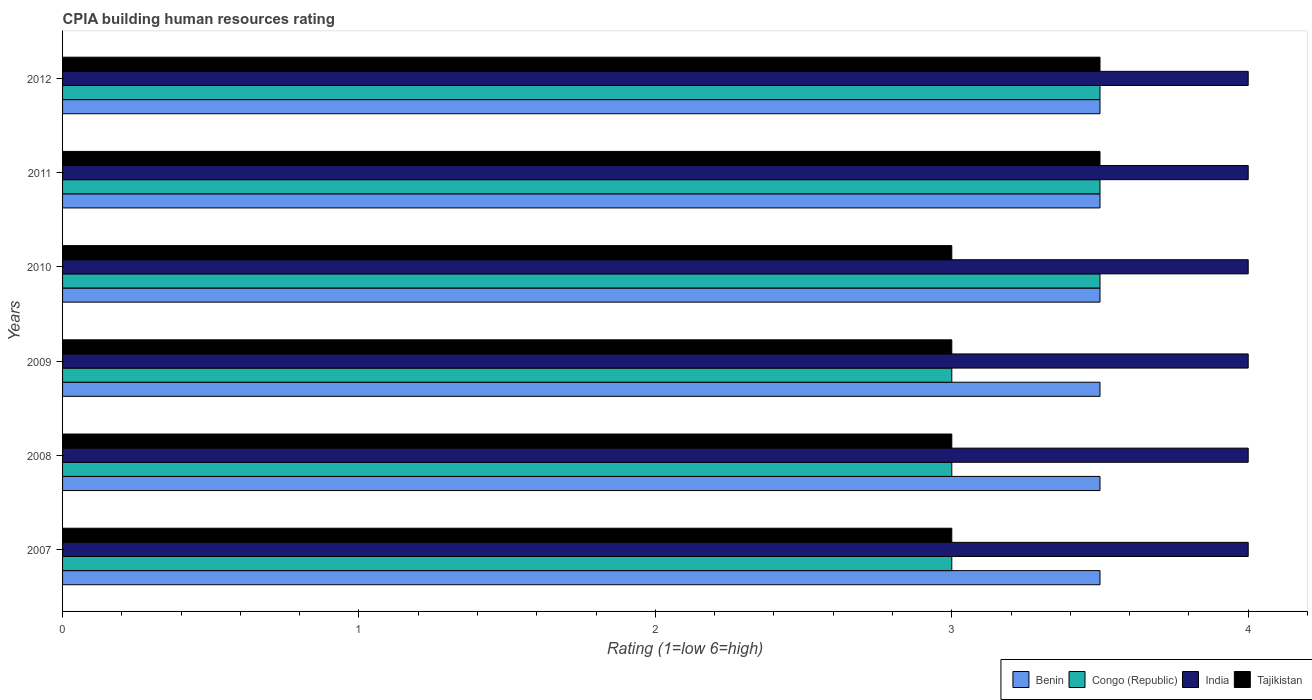What is the label of the 2nd group of bars from the top?
Provide a succinct answer. 2011. In how many cases, is the number of bars for a given year not equal to the number of legend labels?
Keep it short and to the point. 0. Across all years, what is the minimum CPIA rating in Congo (Republic)?
Your response must be concise. 3. In which year was the CPIA rating in Tajikistan maximum?
Keep it short and to the point. 2011. In which year was the CPIA rating in India minimum?
Your response must be concise. 2007. What is the difference between the CPIA rating in Tajikistan in 2007 and that in 2011?
Your answer should be very brief. -0.5. In the year 2009, what is the difference between the CPIA rating in Congo (Republic) and CPIA rating in Tajikistan?
Offer a very short reply. 0. Is the CPIA rating in India in 2009 less than that in 2011?
Your answer should be compact. No. Is the difference between the CPIA rating in Congo (Republic) in 2008 and 2012 greater than the difference between the CPIA rating in Tajikistan in 2008 and 2012?
Keep it short and to the point. No. What is the difference between the highest and the second highest CPIA rating in Congo (Republic)?
Keep it short and to the point. 0. What is the difference between the highest and the lowest CPIA rating in Benin?
Provide a succinct answer. 0. In how many years, is the CPIA rating in India greater than the average CPIA rating in India taken over all years?
Offer a terse response. 0. Is the sum of the CPIA rating in Congo (Republic) in 2010 and 2012 greater than the maximum CPIA rating in India across all years?
Your answer should be very brief. Yes. What does the 1st bar from the bottom in 2011 represents?
Your answer should be very brief. Benin. Is it the case that in every year, the sum of the CPIA rating in India and CPIA rating in Congo (Republic) is greater than the CPIA rating in Tajikistan?
Your response must be concise. Yes. Are all the bars in the graph horizontal?
Your answer should be compact. Yes. How many years are there in the graph?
Keep it short and to the point. 6. What is the difference between two consecutive major ticks on the X-axis?
Offer a very short reply. 1. Does the graph contain any zero values?
Ensure brevity in your answer.  No. Does the graph contain grids?
Give a very brief answer. No. Where does the legend appear in the graph?
Make the answer very short. Bottom right. How are the legend labels stacked?
Provide a short and direct response. Horizontal. What is the title of the graph?
Give a very brief answer. CPIA building human resources rating. What is the Rating (1=low 6=high) in Benin in 2007?
Your answer should be compact. 3.5. What is the Rating (1=low 6=high) of Congo (Republic) in 2007?
Offer a terse response. 3. What is the Rating (1=low 6=high) in Tajikistan in 2007?
Provide a short and direct response. 3. What is the Rating (1=low 6=high) of Benin in 2008?
Keep it short and to the point. 3.5. What is the Rating (1=low 6=high) in Congo (Republic) in 2008?
Make the answer very short. 3. What is the Rating (1=low 6=high) of India in 2008?
Keep it short and to the point. 4. What is the Rating (1=low 6=high) of Benin in 2009?
Give a very brief answer. 3.5. What is the Rating (1=low 6=high) in Congo (Republic) in 2009?
Ensure brevity in your answer.  3. What is the Rating (1=low 6=high) of India in 2009?
Give a very brief answer. 4. What is the Rating (1=low 6=high) in Tajikistan in 2009?
Offer a very short reply. 3. What is the Rating (1=low 6=high) of Benin in 2010?
Keep it short and to the point. 3.5. What is the Rating (1=low 6=high) of Benin in 2011?
Provide a succinct answer. 3.5. What is the Rating (1=low 6=high) of India in 2011?
Ensure brevity in your answer.  4. What is the Rating (1=low 6=high) in Tajikistan in 2011?
Offer a very short reply. 3.5. What is the Rating (1=low 6=high) in Benin in 2012?
Offer a terse response. 3.5. What is the Rating (1=low 6=high) of Tajikistan in 2012?
Give a very brief answer. 3.5. Across all years, what is the maximum Rating (1=low 6=high) in Congo (Republic)?
Provide a short and direct response. 3.5. Across all years, what is the maximum Rating (1=low 6=high) in India?
Offer a very short reply. 4. Across all years, what is the minimum Rating (1=low 6=high) in Congo (Republic)?
Keep it short and to the point. 3. What is the total Rating (1=low 6=high) in Congo (Republic) in the graph?
Keep it short and to the point. 19.5. What is the total Rating (1=low 6=high) in India in the graph?
Offer a terse response. 24. What is the total Rating (1=low 6=high) in Tajikistan in the graph?
Give a very brief answer. 19. What is the difference between the Rating (1=low 6=high) of Benin in 2007 and that in 2008?
Make the answer very short. 0. What is the difference between the Rating (1=low 6=high) in Congo (Republic) in 2007 and that in 2008?
Your answer should be very brief. 0. What is the difference between the Rating (1=low 6=high) in Tajikistan in 2007 and that in 2008?
Your response must be concise. 0. What is the difference between the Rating (1=low 6=high) of Congo (Republic) in 2007 and that in 2009?
Give a very brief answer. 0. What is the difference between the Rating (1=low 6=high) in Congo (Republic) in 2007 and that in 2011?
Ensure brevity in your answer.  -0.5. What is the difference between the Rating (1=low 6=high) in India in 2007 and that in 2011?
Your answer should be very brief. 0. What is the difference between the Rating (1=low 6=high) of Tajikistan in 2007 and that in 2011?
Provide a succinct answer. -0.5. What is the difference between the Rating (1=low 6=high) of India in 2007 and that in 2012?
Your response must be concise. 0. What is the difference between the Rating (1=low 6=high) in Tajikistan in 2007 and that in 2012?
Make the answer very short. -0.5. What is the difference between the Rating (1=low 6=high) of India in 2008 and that in 2009?
Your answer should be compact. 0. What is the difference between the Rating (1=low 6=high) in Tajikistan in 2008 and that in 2009?
Offer a terse response. 0. What is the difference between the Rating (1=low 6=high) of Benin in 2008 and that in 2010?
Ensure brevity in your answer.  0. What is the difference between the Rating (1=low 6=high) in India in 2008 and that in 2010?
Ensure brevity in your answer.  0. What is the difference between the Rating (1=low 6=high) of Tajikistan in 2008 and that in 2010?
Provide a short and direct response. 0. What is the difference between the Rating (1=low 6=high) of Benin in 2008 and that in 2011?
Offer a terse response. 0. What is the difference between the Rating (1=low 6=high) in Congo (Republic) in 2008 and that in 2011?
Offer a terse response. -0.5. What is the difference between the Rating (1=low 6=high) in India in 2009 and that in 2010?
Give a very brief answer. 0. What is the difference between the Rating (1=low 6=high) in Benin in 2009 and that in 2011?
Offer a very short reply. 0. What is the difference between the Rating (1=low 6=high) in Congo (Republic) in 2009 and that in 2011?
Offer a terse response. -0.5. What is the difference between the Rating (1=low 6=high) in Tajikistan in 2009 and that in 2011?
Keep it short and to the point. -0.5. What is the difference between the Rating (1=low 6=high) in Congo (Republic) in 2009 and that in 2012?
Provide a succinct answer. -0.5. What is the difference between the Rating (1=low 6=high) of Tajikistan in 2009 and that in 2012?
Provide a short and direct response. -0.5. What is the difference between the Rating (1=low 6=high) in Benin in 2010 and that in 2011?
Make the answer very short. 0. What is the difference between the Rating (1=low 6=high) of Congo (Republic) in 2010 and that in 2011?
Ensure brevity in your answer.  0. What is the difference between the Rating (1=low 6=high) of India in 2010 and that in 2011?
Offer a very short reply. 0. What is the difference between the Rating (1=low 6=high) in Tajikistan in 2010 and that in 2012?
Give a very brief answer. -0.5. What is the difference between the Rating (1=low 6=high) in Benin in 2011 and that in 2012?
Make the answer very short. 0. What is the difference between the Rating (1=low 6=high) of India in 2011 and that in 2012?
Offer a terse response. 0. What is the difference between the Rating (1=low 6=high) in Benin in 2007 and the Rating (1=low 6=high) in Congo (Republic) in 2008?
Your response must be concise. 0.5. What is the difference between the Rating (1=low 6=high) of India in 2007 and the Rating (1=low 6=high) of Tajikistan in 2008?
Your response must be concise. 1. What is the difference between the Rating (1=low 6=high) of Benin in 2007 and the Rating (1=low 6=high) of Congo (Republic) in 2009?
Make the answer very short. 0.5. What is the difference between the Rating (1=low 6=high) of Benin in 2007 and the Rating (1=low 6=high) of India in 2009?
Offer a terse response. -0.5. What is the difference between the Rating (1=low 6=high) of Benin in 2007 and the Rating (1=low 6=high) of Tajikistan in 2009?
Your answer should be compact. 0.5. What is the difference between the Rating (1=low 6=high) of Congo (Republic) in 2007 and the Rating (1=low 6=high) of India in 2009?
Your answer should be compact. -1. What is the difference between the Rating (1=low 6=high) in Benin in 2007 and the Rating (1=low 6=high) in Congo (Republic) in 2010?
Give a very brief answer. 0. What is the difference between the Rating (1=low 6=high) of Benin in 2007 and the Rating (1=low 6=high) of India in 2010?
Keep it short and to the point. -0.5. What is the difference between the Rating (1=low 6=high) of Benin in 2007 and the Rating (1=low 6=high) of Tajikistan in 2010?
Your answer should be very brief. 0.5. What is the difference between the Rating (1=low 6=high) in Congo (Republic) in 2007 and the Rating (1=low 6=high) in India in 2010?
Ensure brevity in your answer.  -1. What is the difference between the Rating (1=low 6=high) in India in 2007 and the Rating (1=low 6=high) in Tajikistan in 2010?
Keep it short and to the point. 1. What is the difference between the Rating (1=low 6=high) of Congo (Republic) in 2007 and the Rating (1=low 6=high) of India in 2011?
Provide a short and direct response. -1. What is the difference between the Rating (1=low 6=high) of Congo (Republic) in 2007 and the Rating (1=low 6=high) of Tajikistan in 2011?
Make the answer very short. -0.5. What is the difference between the Rating (1=low 6=high) of India in 2007 and the Rating (1=low 6=high) of Tajikistan in 2011?
Offer a terse response. 0.5. What is the difference between the Rating (1=low 6=high) of Benin in 2007 and the Rating (1=low 6=high) of Congo (Republic) in 2012?
Provide a short and direct response. 0. What is the difference between the Rating (1=low 6=high) in Benin in 2007 and the Rating (1=low 6=high) in India in 2012?
Your response must be concise. -0.5. What is the difference between the Rating (1=low 6=high) of Benin in 2007 and the Rating (1=low 6=high) of Tajikistan in 2012?
Keep it short and to the point. 0. What is the difference between the Rating (1=low 6=high) in Congo (Republic) in 2007 and the Rating (1=low 6=high) in India in 2012?
Ensure brevity in your answer.  -1. What is the difference between the Rating (1=low 6=high) of Congo (Republic) in 2007 and the Rating (1=low 6=high) of Tajikistan in 2012?
Make the answer very short. -0.5. What is the difference between the Rating (1=low 6=high) in Benin in 2008 and the Rating (1=low 6=high) in India in 2009?
Offer a very short reply. -0.5. What is the difference between the Rating (1=low 6=high) of Congo (Republic) in 2008 and the Rating (1=low 6=high) of India in 2010?
Ensure brevity in your answer.  -1. What is the difference between the Rating (1=low 6=high) of Benin in 2008 and the Rating (1=low 6=high) of Congo (Republic) in 2011?
Your answer should be compact. 0. What is the difference between the Rating (1=low 6=high) in Benin in 2008 and the Rating (1=low 6=high) in Tajikistan in 2011?
Offer a terse response. 0. What is the difference between the Rating (1=low 6=high) of Congo (Republic) in 2008 and the Rating (1=low 6=high) of Tajikistan in 2011?
Ensure brevity in your answer.  -0.5. What is the difference between the Rating (1=low 6=high) of Benin in 2008 and the Rating (1=low 6=high) of India in 2012?
Give a very brief answer. -0.5. What is the difference between the Rating (1=low 6=high) in India in 2008 and the Rating (1=low 6=high) in Tajikistan in 2012?
Give a very brief answer. 0.5. What is the difference between the Rating (1=low 6=high) in Benin in 2009 and the Rating (1=low 6=high) in India in 2010?
Offer a very short reply. -0.5. What is the difference between the Rating (1=low 6=high) in Benin in 2009 and the Rating (1=low 6=high) in Tajikistan in 2010?
Your answer should be compact. 0.5. What is the difference between the Rating (1=low 6=high) of Congo (Republic) in 2009 and the Rating (1=low 6=high) of Tajikistan in 2010?
Your answer should be compact. 0. What is the difference between the Rating (1=low 6=high) of India in 2009 and the Rating (1=low 6=high) of Tajikistan in 2010?
Give a very brief answer. 1. What is the difference between the Rating (1=low 6=high) in Congo (Republic) in 2009 and the Rating (1=low 6=high) in India in 2011?
Your response must be concise. -1. What is the difference between the Rating (1=low 6=high) of India in 2009 and the Rating (1=low 6=high) of Tajikistan in 2011?
Give a very brief answer. 0.5. What is the difference between the Rating (1=low 6=high) of Benin in 2009 and the Rating (1=low 6=high) of Congo (Republic) in 2012?
Provide a short and direct response. 0. What is the difference between the Rating (1=low 6=high) in Benin in 2009 and the Rating (1=low 6=high) in India in 2012?
Ensure brevity in your answer.  -0.5. What is the difference between the Rating (1=low 6=high) of Benin in 2009 and the Rating (1=low 6=high) of Tajikistan in 2012?
Your answer should be compact. 0. What is the difference between the Rating (1=low 6=high) of Congo (Republic) in 2009 and the Rating (1=low 6=high) of Tajikistan in 2012?
Offer a very short reply. -0.5. What is the difference between the Rating (1=low 6=high) of India in 2009 and the Rating (1=low 6=high) of Tajikistan in 2012?
Keep it short and to the point. 0.5. What is the difference between the Rating (1=low 6=high) in Benin in 2010 and the Rating (1=low 6=high) in Congo (Republic) in 2011?
Keep it short and to the point. 0. What is the difference between the Rating (1=low 6=high) of Benin in 2010 and the Rating (1=low 6=high) of Tajikistan in 2011?
Your response must be concise. 0. What is the difference between the Rating (1=low 6=high) in Congo (Republic) in 2010 and the Rating (1=low 6=high) in India in 2011?
Your answer should be very brief. -0.5. What is the difference between the Rating (1=low 6=high) in Congo (Republic) in 2010 and the Rating (1=low 6=high) in Tajikistan in 2011?
Ensure brevity in your answer.  0. What is the difference between the Rating (1=low 6=high) in India in 2010 and the Rating (1=low 6=high) in Tajikistan in 2011?
Provide a succinct answer. 0.5. What is the difference between the Rating (1=low 6=high) of Benin in 2010 and the Rating (1=low 6=high) of India in 2012?
Offer a terse response. -0.5. What is the difference between the Rating (1=low 6=high) of Benin in 2010 and the Rating (1=low 6=high) of Tajikistan in 2012?
Your answer should be compact. 0. What is the difference between the Rating (1=low 6=high) of Congo (Republic) in 2010 and the Rating (1=low 6=high) of India in 2012?
Your answer should be compact. -0.5. What is the difference between the Rating (1=low 6=high) of Congo (Republic) in 2010 and the Rating (1=low 6=high) of Tajikistan in 2012?
Make the answer very short. 0. What is the difference between the Rating (1=low 6=high) in Benin in 2011 and the Rating (1=low 6=high) in Congo (Republic) in 2012?
Ensure brevity in your answer.  0. What is the difference between the Rating (1=low 6=high) of Benin in 2011 and the Rating (1=low 6=high) of India in 2012?
Provide a succinct answer. -0.5. What is the difference between the Rating (1=low 6=high) of Congo (Republic) in 2011 and the Rating (1=low 6=high) of Tajikistan in 2012?
Offer a very short reply. 0. What is the average Rating (1=low 6=high) of Congo (Republic) per year?
Your answer should be very brief. 3.25. What is the average Rating (1=low 6=high) of Tajikistan per year?
Offer a very short reply. 3.17. In the year 2007, what is the difference between the Rating (1=low 6=high) in Congo (Republic) and Rating (1=low 6=high) in India?
Provide a short and direct response. -1. In the year 2007, what is the difference between the Rating (1=low 6=high) of Congo (Republic) and Rating (1=low 6=high) of Tajikistan?
Provide a short and direct response. 0. In the year 2008, what is the difference between the Rating (1=low 6=high) of Benin and Rating (1=low 6=high) of Congo (Republic)?
Give a very brief answer. 0.5. In the year 2008, what is the difference between the Rating (1=low 6=high) in Benin and Rating (1=low 6=high) in Tajikistan?
Offer a terse response. 0.5. In the year 2008, what is the difference between the Rating (1=low 6=high) of Congo (Republic) and Rating (1=low 6=high) of India?
Ensure brevity in your answer.  -1. In the year 2008, what is the difference between the Rating (1=low 6=high) of Congo (Republic) and Rating (1=low 6=high) of Tajikistan?
Make the answer very short. 0. In the year 2009, what is the difference between the Rating (1=low 6=high) in Benin and Rating (1=low 6=high) in India?
Your response must be concise. -0.5. In the year 2009, what is the difference between the Rating (1=low 6=high) in Congo (Republic) and Rating (1=low 6=high) in India?
Provide a short and direct response. -1. In the year 2009, what is the difference between the Rating (1=low 6=high) of Congo (Republic) and Rating (1=low 6=high) of Tajikistan?
Your answer should be compact. 0. In the year 2010, what is the difference between the Rating (1=low 6=high) in Benin and Rating (1=low 6=high) in Congo (Republic)?
Keep it short and to the point. 0. In the year 2010, what is the difference between the Rating (1=low 6=high) of Benin and Rating (1=low 6=high) of India?
Your answer should be compact. -0.5. In the year 2010, what is the difference between the Rating (1=low 6=high) of Benin and Rating (1=low 6=high) of Tajikistan?
Give a very brief answer. 0.5. In the year 2010, what is the difference between the Rating (1=low 6=high) in Congo (Republic) and Rating (1=low 6=high) in Tajikistan?
Provide a succinct answer. 0.5. In the year 2010, what is the difference between the Rating (1=low 6=high) in India and Rating (1=low 6=high) in Tajikistan?
Keep it short and to the point. 1. In the year 2011, what is the difference between the Rating (1=low 6=high) in Benin and Rating (1=low 6=high) in Congo (Republic)?
Make the answer very short. 0. In the year 2011, what is the difference between the Rating (1=low 6=high) in Benin and Rating (1=low 6=high) in India?
Provide a succinct answer. -0.5. In the year 2011, what is the difference between the Rating (1=low 6=high) of Benin and Rating (1=low 6=high) of Tajikistan?
Offer a terse response. 0. In the year 2011, what is the difference between the Rating (1=low 6=high) of India and Rating (1=low 6=high) of Tajikistan?
Ensure brevity in your answer.  0.5. In the year 2012, what is the difference between the Rating (1=low 6=high) of Benin and Rating (1=low 6=high) of India?
Provide a succinct answer. -0.5. In the year 2012, what is the difference between the Rating (1=low 6=high) in Congo (Republic) and Rating (1=low 6=high) in Tajikistan?
Keep it short and to the point. 0. What is the ratio of the Rating (1=low 6=high) of Tajikistan in 2007 to that in 2008?
Make the answer very short. 1. What is the ratio of the Rating (1=low 6=high) in India in 2007 to that in 2009?
Make the answer very short. 1. What is the ratio of the Rating (1=low 6=high) in Tajikistan in 2007 to that in 2009?
Keep it short and to the point. 1. What is the ratio of the Rating (1=low 6=high) of Benin in 2007 to that in 2010?
Your response must be concise. 1. What is the ratio of the Rating (1=low 6=high) in Congo (Republic) in 2007 to that in 2010?
Offer a very short reply. 0.86. What is the ratio of the Rating (1=low 6=high) in Congo (Republic) in 2007 to that in 2011?
Keep it short and to the point. 0.86. What is the ratio of the Rating (1=low 6=high) of Tajikistan in 2007 to that in 2011?
Make the answer very short. 0.86. What is the ratio of the Rating (1=low 6=high) in India in 2007 to that in 2012?
Provide a succinct answer. 1. What is the ratio of the Rating (1=low 6=high) of Benin in 2008 to that in 2009?
Offer a very short reply. 1. What is the ratio of the Rating (1=low 6=high) in Tajikistan in 2008 to that in 2009?
Make the answer very short. 1. What is the ratio of the Rating (1=low 6=high) of Benin in 2008 to that in 2010?
Keep it short and to the point. 1. What is the ratio of the Rating (1=low 6=high) of India in 2008 to that in 2010?
Offer a very short reply. 1. What is the ratio of the Rating (1=low 6=high) in Tajikistan in 2008 to that in 2010?
Make the answer very short. 1. What is the ratio of the Rating (1=low 6=high) of Tajikistan in 2008 to that in 2011?
Provide a short and direct response. 0.86. What is the ratio of the Rating (1=low 6=high) of Congo (Republic) in 2008 to that in 2012?
Keep it short and to the point. 0.86. What is the ratio of the Rating (1=low 6=high) of India in 2008 to that in 2012?
Offer a terse response. 1. What is the ratio of the Rating (1=low 6=high) in India in 2009 to that in 2010?
Provide a short and direct response. 1. What is the ratio of the Rating (1=low 6=high) in Benin in 2009 to that in 2011?
Your answer should be compact. 1. What is the ratio of the Rating (1=low 6=high) in Congo (Republic) in 2009 to that in 2011?
Give a very brief answer. 0.86. What is the ratio of the Rating (1=low 6=high) in India in 2009 to that in 2011?
Offer a very short reply. 1. What is the ratio of the Rating (1=low 6=high) of Benin in 2009 to that in 2012?
Provide a short and direct response. 1. What is the ratio of the Rating (1=low 6=high) in Congo (Republic) in 2009 to that in 2012?
Offer a terse response. 0.86. What is the ratio of the Rating (1=low 6=high) of Tajikistan in 2009 to that in 2012?
Your response must be concise. 0.86. What is the ratio of the Rating (1=low 6=high) in India in 2010 to that in 2011?
Provide a short and direct response. 1. What is the ratio of the Rating (1=low 6=high) in Benin in 2010 to that in 2012?
Your response must be concise. 1. What is the difference between the highest and the second highest Rating (1=low 6=high) in Congo (Republic)?
Your answer should be compact. 0. What is the difference between the highest and the second highest Rating (1=low 6=high) in Tajikistan?
Make the answer very short. 0. What is the difference between the highest and the lowest Rating (1=low 6=high) in Benin?
Offer a terse response. 0. What is the difference between the highest and the lowest Rating (1=low 6=high) of India?
Your response must be concise. 0. 